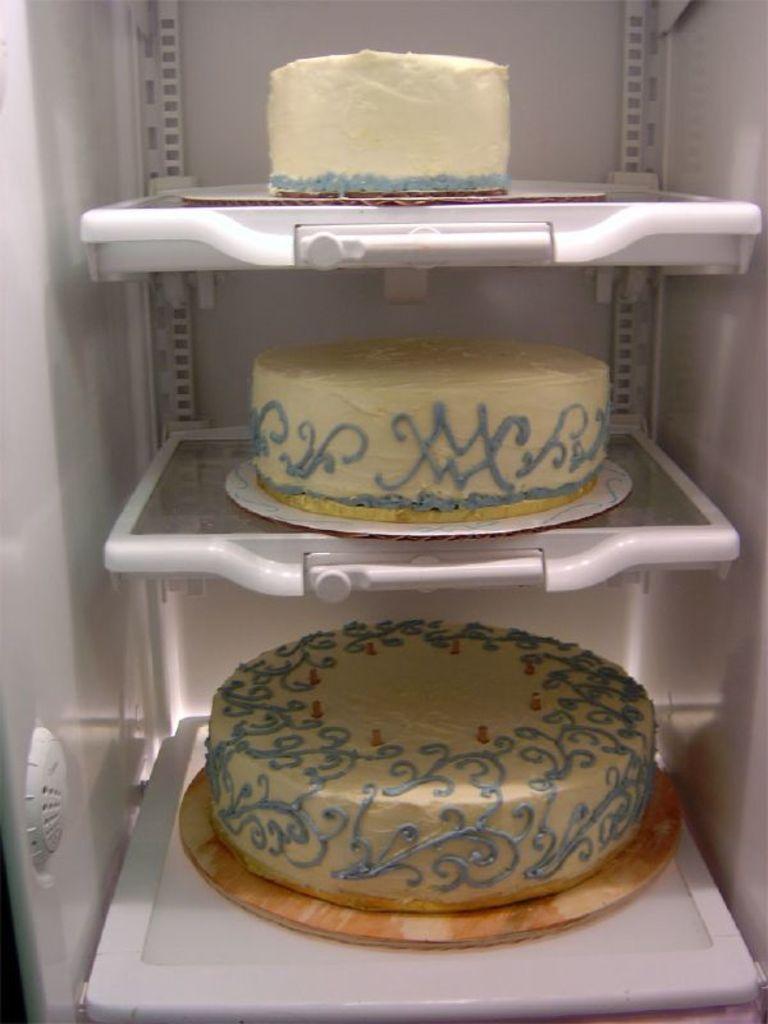Could you give a brief overview of what you see in this image? In this picture I can see 3 cakes in the refrigerator. 